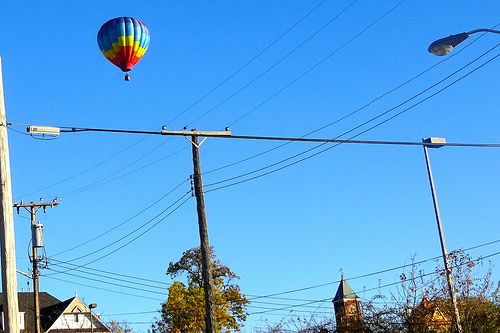<image>
Is the wooden post under the balloon? Yes. The wooden post is positioned underneath the balloon, with the balloon above it in the vertical space. 